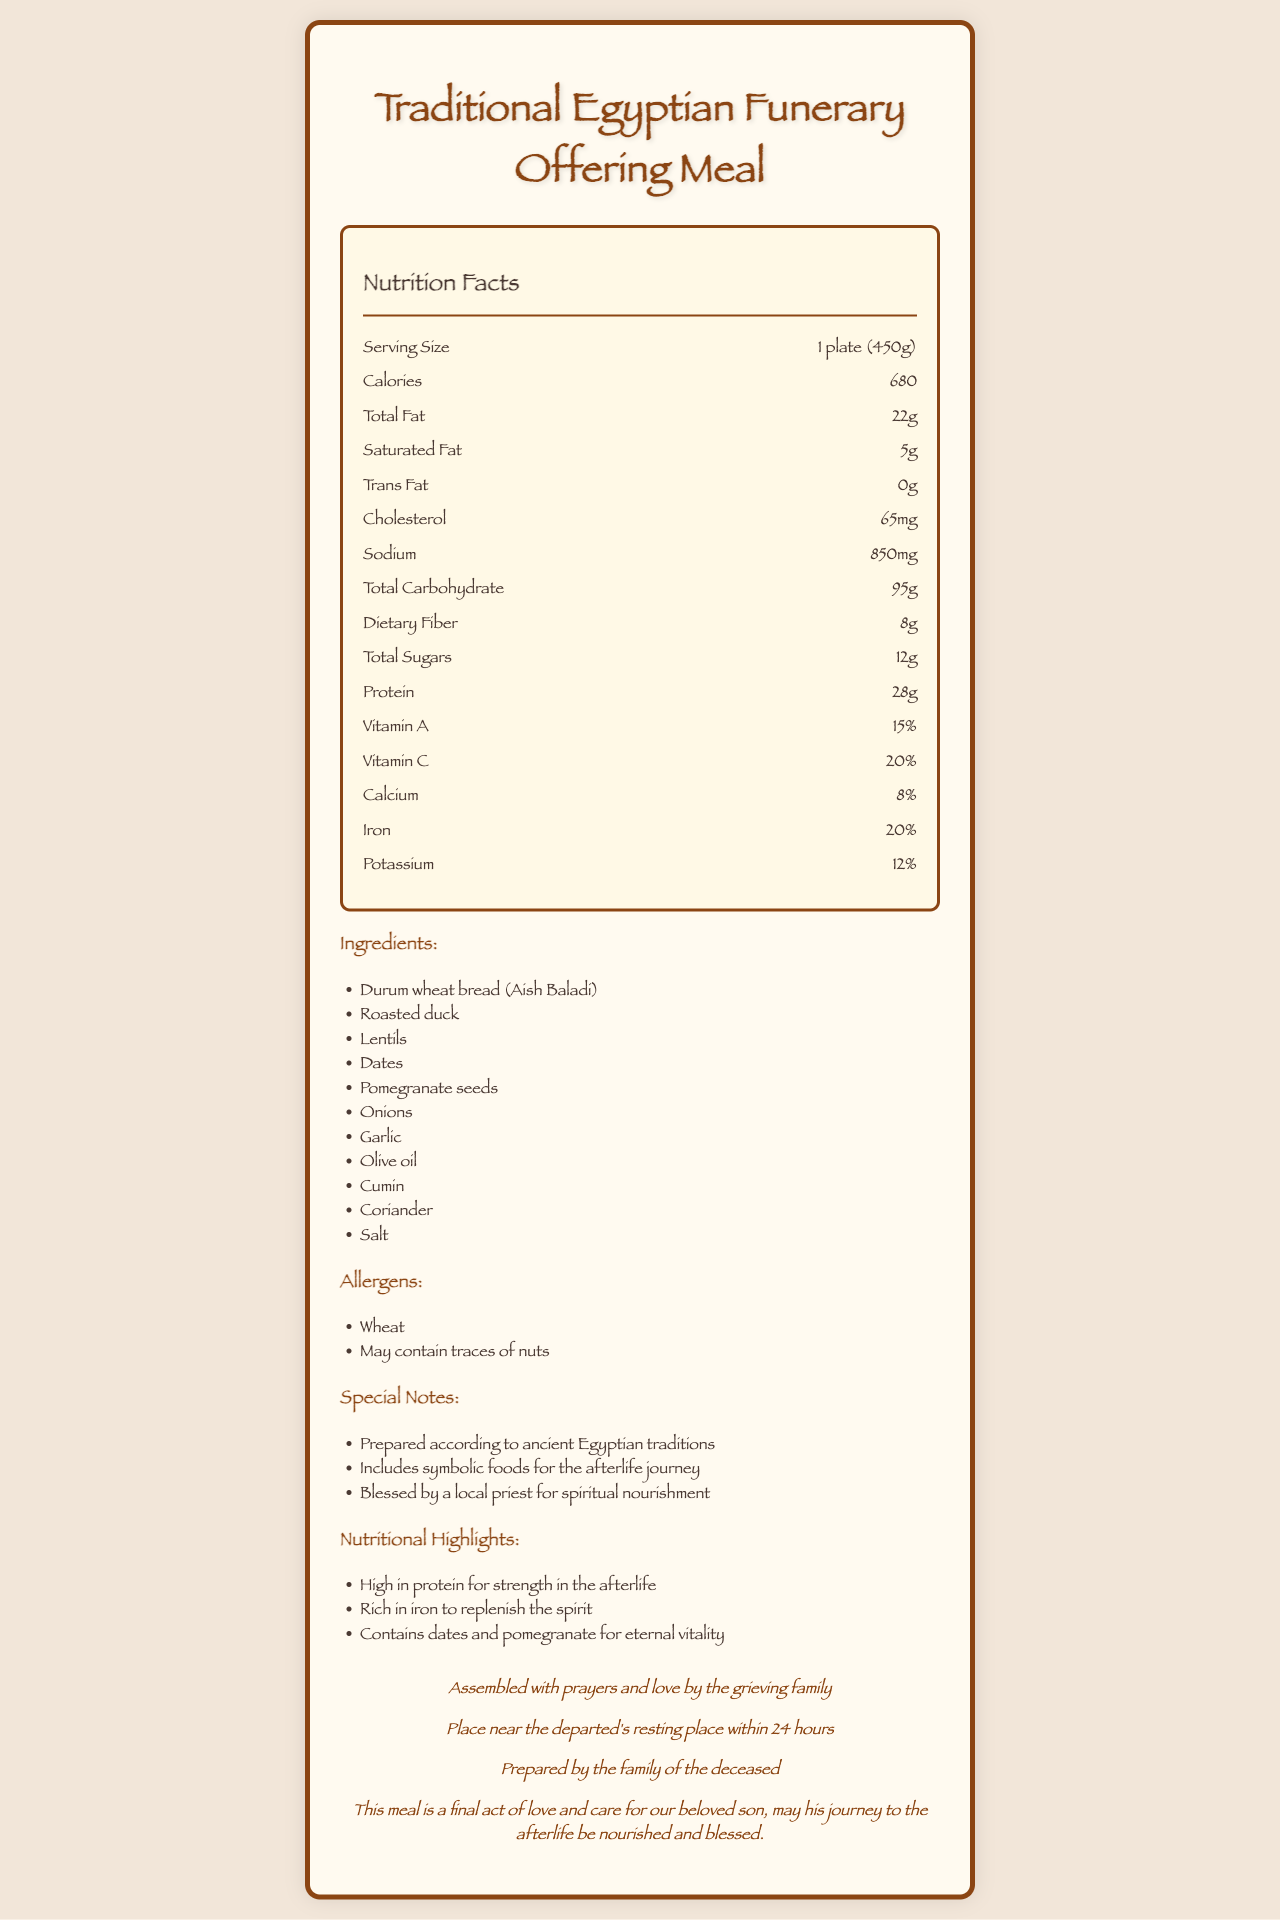What is the serving size of the Traditional Egyptian Funerary Offering Meal? The document lists the serving size as "1 plate (450g)" under the nutrition label section.
Answer: 1 plate (450g) How many total calories does the meal contain? The document shows that there are 680 calories per serving.
Answer: 680 What is the total fat content in the meal? According to the nutrition facts in the document, the total fat content is 22 grams.
Answer: 22g List two symbolic foods included in the ingredients. The ingredients list includes dates and pomegranate seeds, which are highlighted as symbolic foods for eternal vitality.
Answer: Dates, Pomegranate seeds Name one of the allergens present in the meal. The allergens section lists "Wheat" as one of the allergens.
Answer: Wheat What is the percentage of daily value for iron in this meal? The document states that the iron content is 20% of the daily value.
Answer: 20% How much dietary fiber is in the meal? The dietary fiber content is 8 grams as listed in the nutrition facts.
Answer: 8g What kind of oil is used to prepare the meal? The ingredient list includes "Olive oil."
Answer: Olive oil Which of the following is NOT an ingredient in the meal? A. Lentils B. Dates C. Rice D. Onions The ingredient list includes lentils, dates, and onions, but not rice.
Answer: C. Rice How is the preparation of the meal described? A. Boiled with herbs B. Roasted with spices C. Assembled with prayers and love D. Fried in olive oil The preparation method mentioned is "Assembled with prayers and love by the grieving family."
Answer: C. Assembled with prayers and love Is the meal high in protein? The nutritional highlights explicitly state that the meal is high in protein for strength in the afterlife.
Answer: Yes Summarize the main idea of the document. The document covers various aspects of the Traditional Egyptian Funerary Offering Meal including its nutritional facts, ingredients, allergens, special notes about its cultural and symbolic importance, its nutritional highlights, preparation, and storage instructions.
Answer: This document provides the nutritional information and special details about the Traditional Egyptian Funerary Offering Meal, highlighting its ingredients, symbolic significance, nutritional benefits, and preparation details. Who is the manufacturer of the meal? The document notes that the meal is prepared by the family of the deceased.
Answer: Prepared by the family of the deceased What is the potassium content in the meal? The document indicates that the potassium content is 12% of the daily value.
Answer: 12% What type of bread is used in the ingredient list? The ingredients section lists "Durum wheat bread (Aish Baladi)" among the components.
Answer: Durum wheat bread (Aish Baladi) How does the document suggest storing the meal? The storage instructions indicate that the meal should be placed near the departed's resting place within 24 hours.
Answer: Place near the departed's resting place within 24 hours Where was the meal blessed? The document mentions the meal is blessed by a local priest for spiritual nourishment but does not specify the location.
Answer: Not enough information 